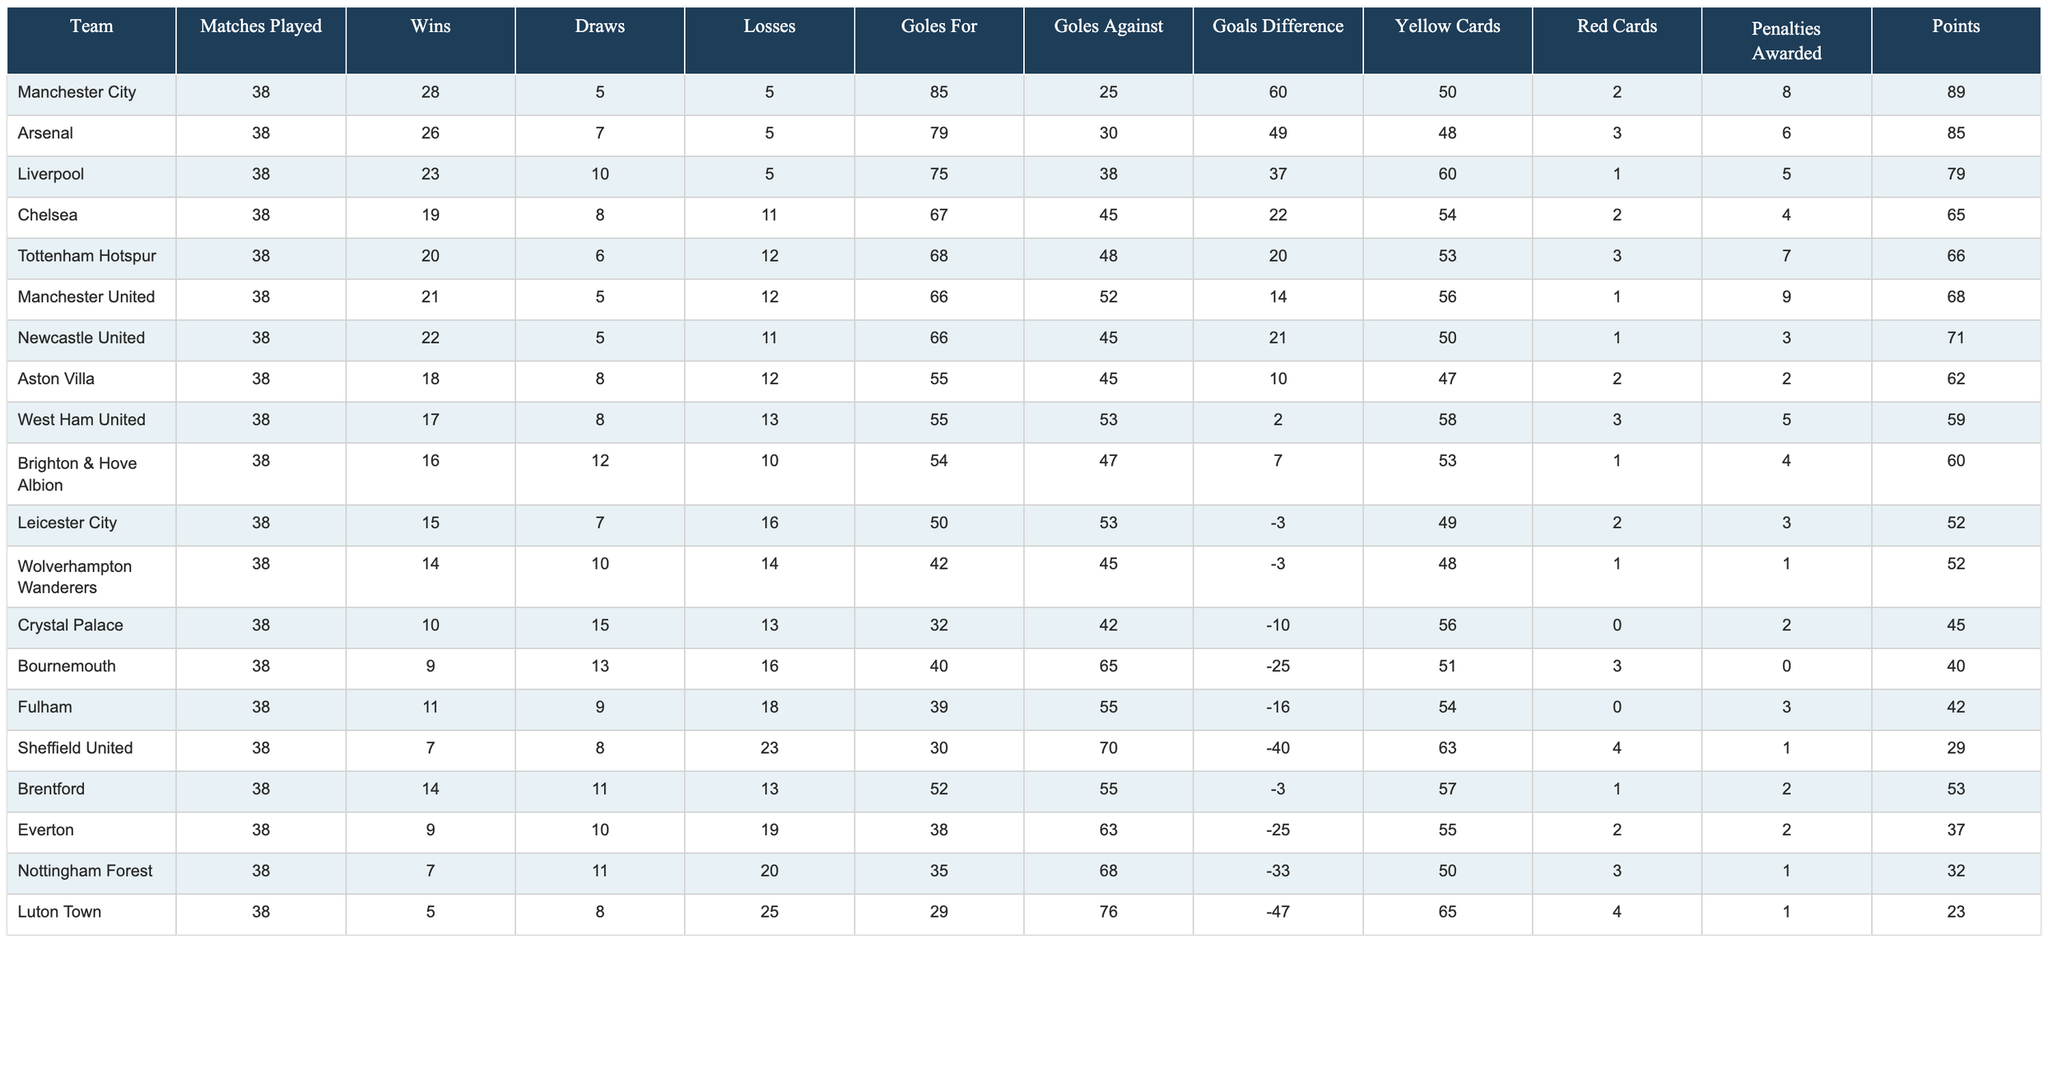What team had the most wins in the 2023 season? Manchester City has the highest wins at 28, as indicated in the "Wins" column.
Answer: Manchester City Which team had the highest goals against in the season? Bournemouth allowed the most goals, with 65 against them, as seen in the "Goles Against" column.
Answer: Bournemouth What was the total number of points earned by Arsenal and Liverpool combined? Arsenal earned 85 points and Liverpool earned 79 points. Adding them gives 85 + 79 = 164 points.
Answer: 164 How many teams had more than 20 wins? Manchester City, Arsenal, Liverpool, Newcastle United, and Tottenham Hotspur had more than 20 wins. That's 5 teams.
Answer: 5 What is the goal difference for Chelsea? Chelsea's goal difference is calculated as goals for (67) minus goals against (45), which is 67 - 45 = 22.
Answer: 22 Was there any team that finished with a negative goals difference? Yes, both Leicester City and Wolverhampton Wanderers had a negative goals difference of -3.
Answer: Yes What is the average number of yellow cards received by teams who finished with more than 60 points? The teams with more than 60 points are Manchester City, Arsenal, Liverpool, Chelsea, Tottenham, Manchester United, Newcastle United, and Brentford. Their yellow cards total 50 + 48 + 60 + 54 + 53 + 56 + 50 + 57 = 428. There are 8 teams, so the average is 428/8 = 53.5.
Answer: 53.5 Which team had the most red cards? Manchester City and Tottenham Hotspur both had the most red cards with 3 each, according to the "Red Cards" column.
Answer: Manchester City, Tottenham Hotspur (tie) What is the difference in points between the first and last team? Manchester City ended with 89 points while Luton Town ended with 23 points. The difference is 89 - 23 = 66 points.
Answer: 66 Did any team win more matches than Arsenal? No, Arsenal's 26 wins are not exceeded by any other team in the table, as Manchester City, the only team with more wins, has 28.
Answer: No 